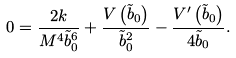Convert formula to latex. <formula><loc_0><loc_0><loc_500><loc_500>0 = \frac { 2 k } { M ^ { 4 } \tilde { b } _ { 0 } ^ { 6 } } + \frac { V \left ( \tilde { b } _ { 0 } \right ) } { \tilde { b } _ { 0 } ^ { 2 } } - \frac { V ^ { \prime } \left ( \tilde { b } _ { 0 } \right ) } { 4 \tilde { b } _ { 0 } } .</formula> 